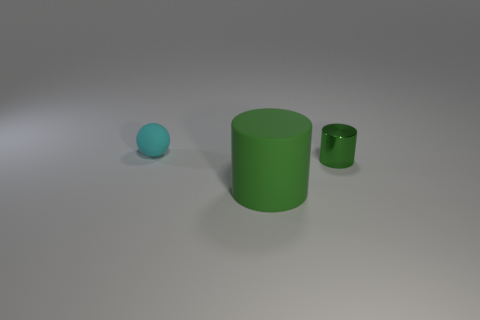Add 1 rubber cylinders. How many objects exist? 4 Subtract all balls. How many objects are left? 2 Subtract 0 cyan cubes. How many objects are left? 3 Subtract all tiny red matte things. Subtract all big green matte cylinders. How many objects are left? 2 Add 2 tiny things. How many tiny things are left? 4 Add 2 yellow metallic objects. How many yellow metallic objects exist? 2 